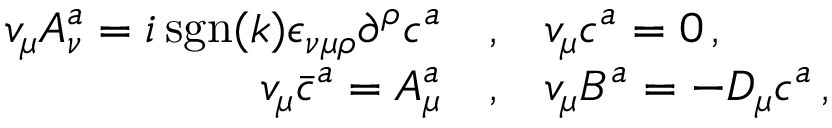Convert formula to latex. <formula><loc_0><loc_0><loc_500><loc_500>\begin{array} { r c l } { { v _ { \mu } A _ { \nu } ^ { a } = i \, s g n ( k ) { \epsilon } _ { \nu \mu \rho } { \partial } ^ { \rho } c ^ { a } } } & { , } & { { v _ { \mu } c ^ { a } = 0 \, , } } \\ { { v _ { \mu } { \bar { c } ^ { a } } = A _ { \mu } ^ { a } } } & { , } & { { v _ { \mu } B ^ { a } = - D _ { \mu } c ^ { a } \, , } } \end{array}</formula> 